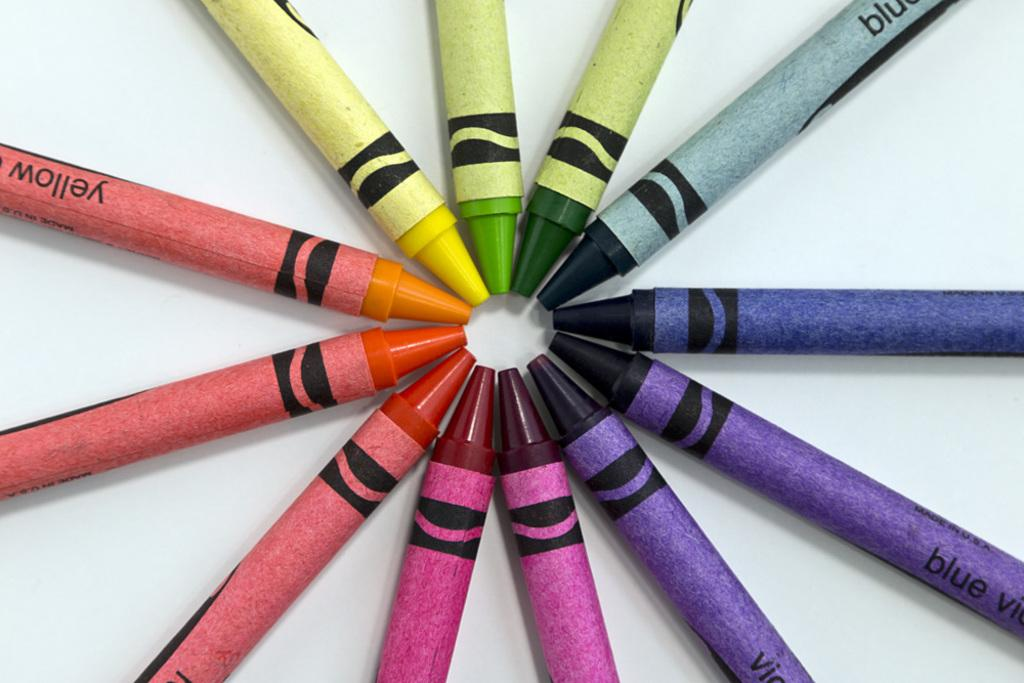<image>
Summarize the visual content of the image. Coloring crayons in shades of yellow, blue and violet arranged in a circle. 